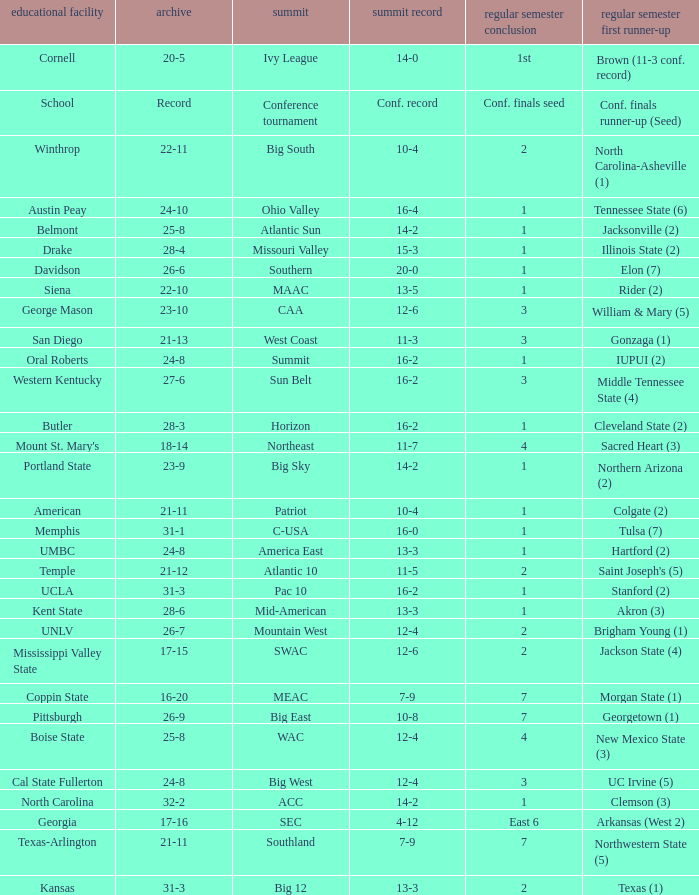What was the overall record of UMBC? 24-8. I'm looking to parse the entire table for insights. Could you assist me with that? {'header': ['educational facility', 'archive', 'summit', 'summit record', 'regular semester conclusion', 'regular semester first runner-up'], 'rows': [['Cornell', '20-5', 'Ivy League', '14-0', '1st', 'Brown (11-3 conf. record)'], ['School', 'Record', 'Conference tournament', 'Conf. record', 'Conf. finals seed', 'Conf. finals runner-up (Seed)'], ['Winthrop', '22-11', 'Big South', '10-4', '2', 'North Carolina-Asheville (1)'], ['Austin Peay', '24-10', 'Ohio Valley', '16-4', '1', 'Tennessee State (6)'], ['Belmont', '25-8', 'Atlantic Sun', '14-2', '1', 'Jacksonville (2)'], ['Drake', '28-4', 'Missouri Valley', '15-3', '1', 'Illinois State (2)'], ['Davidson', '26-6', 'Southern', '20-0', '1', 'Elon (7)'], ['Siena', '22-10', 'MAAC', '13-5', '1', 'Rider (2)'], ['George Mason', '23-10', 'CAA', '12-6', '3', 'William & Mary (5)'], ['San Diego', '21-13', 'West Coast', '11-3', '3', 'Gonzaga (1)'], ['Oral Roberts', '24-8', 'Summit', '16-2', '1', 'IUPUI (2)'], ['Western Kentucky', '27-6', 'Sun Belt', '16-2', '3', 'Middle Tennessee State (4)'], ['Butler', '28-3', 'Horizon', '16-2', '1', 'Cleveland State (2)'], ["Mount St. Mary's", '18-14', 'Northeast', '11-7', '4', 'Sacred Heart (3)'], ['Portland State', '23-9', 'Big Sky', '14-2', '1', 'Northern Arizona (2)'], ['American', '21-11', 'Patriot', '10-4', '1', 'Colgate (2)'], ['Memphis', '31-1', 'C-USA', '16-0', '1', 'Tulsa (7)'], ['UMBC', '24-8', 'America East', '13-3', '1', 'Hartford (2)'], ['Temple', '21-12', 'Atlantic 10', '11-5', '2', "Saint Joseph's (5)"], ['UCLA', '31-3', 'Pac 10', '16-2', '1', 'Stanford (2)'], ['Kent State', '28-6', 'Mid-American', '13-3', '1', 'Akron (3)'], ['UNLV', '26-7', 'Mountain West', '12-4', '2', 'Brigham Young (1)'], ['Mississippi Valley State', '17-15', 'SWAC', '12-6', '2', 'Jackson State (4)'], ['Coppin State', '16-20', 'MEAC', '7-9', '7', 'Morgan State (1)'], ['Pittsburgh', '26-9', 'Big East', '10-8', '7', 'Georgetown (1)'], ['Boise State', '25-8', 'WAC', '12-4', '4', 'New Mexico State (3)'], ['Cal State Fullerton', '24-8', 'Big West', '12-4', '3', 'UC Irvine (5)'], ['North Carolina', '32-2', 'ACC', '14-2', '1', 'Clemson (3)'], ['Georgia', '17-16', 'SEC', '4-12', 'East 6', 'Arkansas (West 2)'], ['Texas-Arlington', '21-11', 'Southland', '7-9', '7', 'Northwestern State (5)'], ['Kansas', '31-3', 'Big 12', '13-3', '2', 'Texas (1)']]} 